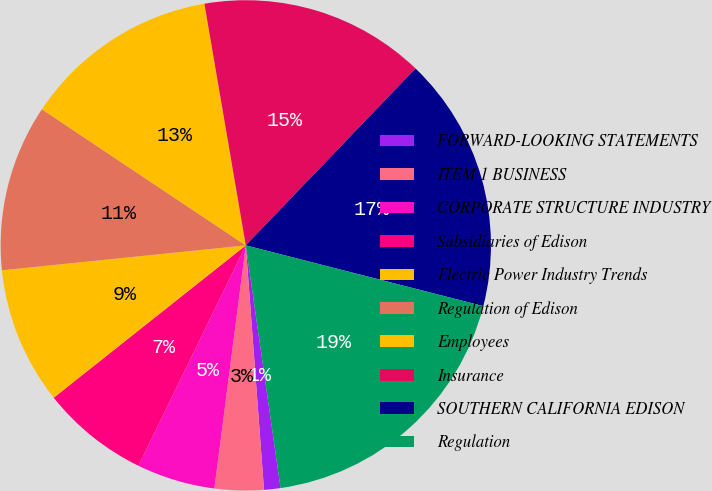Convert chart. <chart><loc_0><loc_0><loc_500><loc_500><pie_chart><fcel>FORWARD-LOOKING STATEMENTS<fcel>ITEM 1 BUSINESS<fcel>CORPORATE STRUCTURE INDUSTRY<fcel>Subsidiaries of Edison<fcel>Electric Power Industry Trends<fcel>Regulation of Edison<fcel>Employees<fcel>Insurance<fcel>SOUTHERN CALIFORNIA EDISON<fcel>Regulation<nl><fcel>1.08%<fcel>3.23%<fcel>5.17%<fcel>7.11%<fcel>9.05%<fcel>10.99%<fcel>12.93%<fcel>14.87%<fcel>16.81%<fcel>18.75%<nl></chart> 